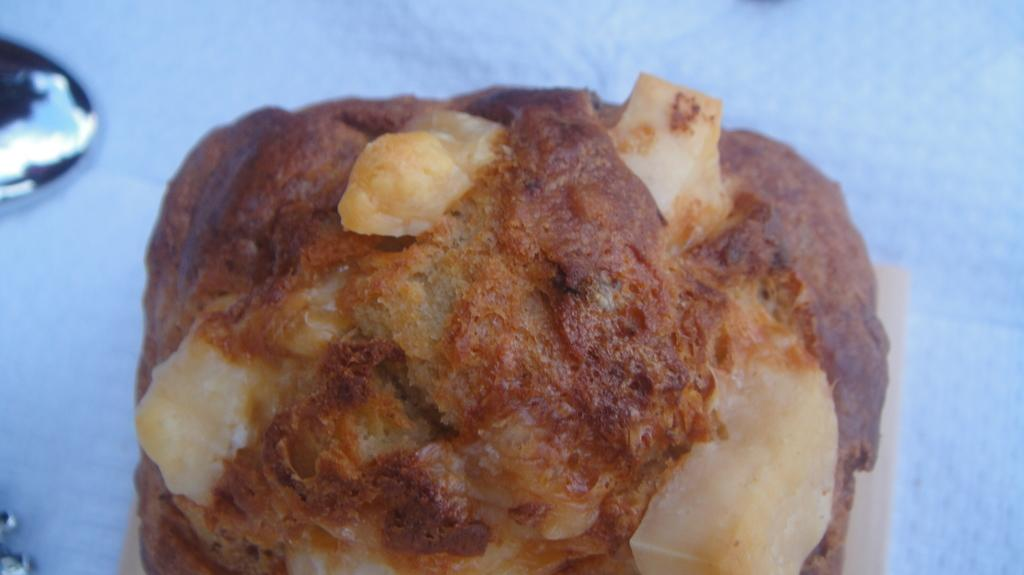What is the main object on the table in the image? There is a food item on the table in the image. Can you describe the other object beside the food item? There is another object beside the food item on the table. How many slaves are visible in the image? There are no slaves present in the image. What type of lettuce is being used as a tablecloth in the image? There is no lettuce present in the image, nor is there a tablecloth. 